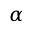<formula> <loc_0><loc_0><loc_500><loc_500>\alpha</formula> 